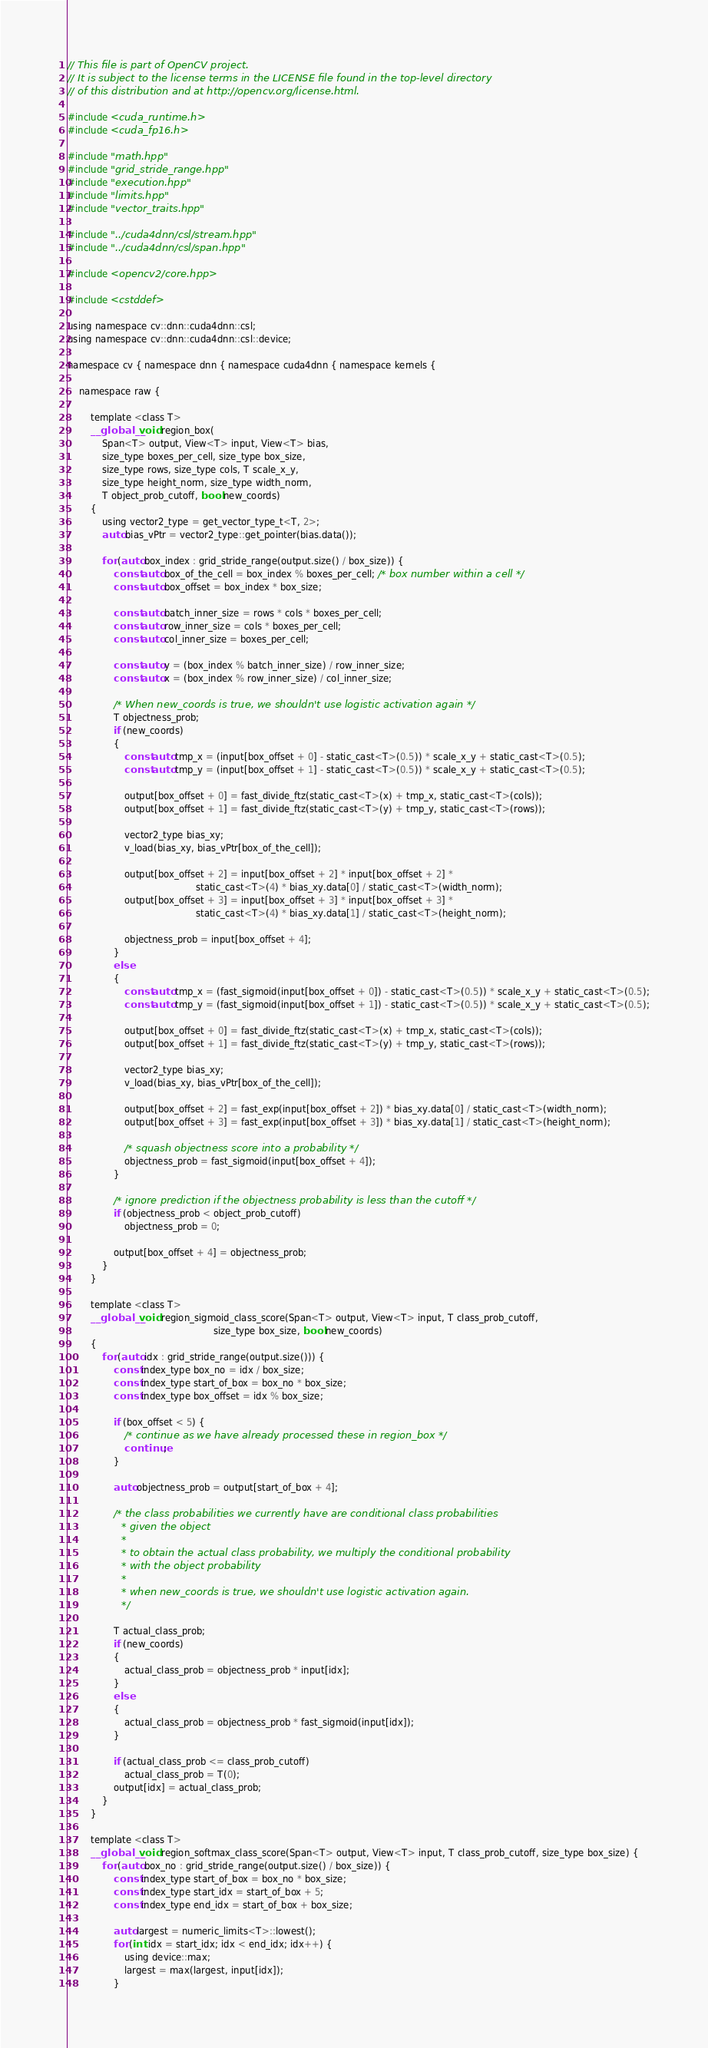Convert code to text. <code><loc_0><loc_0><loc_500><loc_500><_Cuda_>// This file is part of OpenCV project.
// It is subject to the license terms in the LICENSE file found in the top-level directory
// of this distribution and at http://opencv.org/license.html.

#include <cuda_runtime.h>
#include <cuda_fp16.h>

#include "math.hpp"
#include "grid_stride_range.hpp"
#include "execution.hpp"
#include "limits.hpp"
#include "vector_traits.hpp"

#include "../cuda4dnn/csl/stream.hpp"
#include "../cuda4dnn/csl/span.hpp"

#include <opencv2/core.hpp>

#include <cstddef>

using namespace cv::dnn::cuda4dnn::csl;
using namespace cv::dnn::cuda4dnn::csl::device;

namespace cv { namespace dnn { namespace cuda4dnn { namespace kernels {

    namespace raw {

        template <class T>
        __global__ void region_box(
            Span<T> output, View<T> input, View<T> bias,
            size_type boxes_per_cell, size_type box_size,
            size_type rows, size_type cols, T scale_x_y,
            size_type height_norm, size_type width_norm,
            T object_prob_cutoff, bool new_coords)
        {
            using vector2_type = get_vector_type_t<T, 2>;
            auto bias_vPtr = vector2_type::get_pointer(bias.data());

            for (auto box_index : grid_stride_range(output.size() / box_size)) {
                const auto box_of_the_cell = box_index % boxes_per_cell; /* box number within a cell */
                const auto box_offset = box_index * box_size;

                const auto batch_inner_size = rows * cols * boxes_per_cell;
                const auto row_inner_size = cols * boxes_per_cell;
                const auto col_inner_size = boxes_per_cell;

                const auto y = (box_index % batch_inner_size) / row_inner_size;
                const auto x = (box_index % row_inner_size) / col_inner_size;

                /* When new_coords is true, we shouldn't use logistic activation again */
                T objectness_prob;
                if (new_coords)
                {
                    const auto tmp_x = (input[box_offset + 0] - static_cast<T>(0.5)) * scale_x_y + static_cast<T>(0.5);
                    const auto tmp_y = (input[box_offset + 1] - static_cast<T>(0.5)) * scale_x_y + static_cast<T>(0.5);

                    output[box_offset + 0] = fast_divide_ftz(static_cast<T>(x) + tmp_x, static_cast<T>(cols));
                    output[box_offset + 1] = fast_divide_ftz(static_cast<T>(y) + tmp_y, static_cast<T>(rows));

                    vector2_type bias_xy;
                    v_load(bias_xy, bias_vPtr[box_of_the_cell]);

                    output[box_offset + 2] = input[box_offset + 2] * input[box_offset + 2] *
                                             static_cast<T>(4) * bias_xy.data[0] / static_cast<T>(width_norm);
                    output[box_offset + 3] = input[box_offset + 3] * input[box_offset + 3] *
                                             static_cast<T>(4) * bias_xy.data[1] / static_cast<T>(height_norm);

                    objectness_prob = input[box_offset + 4];
                }
                else
                {
                    const auto tmp_x = (fast_sigmoid(input[box_offset + 0]) - static_cast<T>(0.5)) * scale_x_y + static_cast<T>(0.5);
                    const auto tmp_y = (fast_sigmoid(input[box_offset + 1]) - static_cast<T>(0.5)) * scale_x_y + static_cast<T>(0.5);

                    output[box_offset + 0] = fast_divide_ftz(static_cast<T>(x) + tmp_x, static_cast<T>(cols));
                    output[box_offset + 1] = fast_divide_ftz(static_cast<T>(y) + tmp_y, static_cast<T>(rows));

                    vector2_type bias_xy;
                    v_load(bias_xy, bias_vPtr[box_of_the_cell]);

                    output[box_offset + 2] = fast_exp(input[box_offset + 2]) * bias_xy.data[0] / static_cast<T>(width_norm);
                    output[box_offset + 3] = fast_exp(input[box_offset + 3]) * bias_xy.data[1] / static_cast<T>(height_norm);

                    /* squash objectness score into a probability */
                    objectness_prob = fast_sigmoid(input[box_offset + 4]);
                }

                /* ignore prediction if the objectness probability is less than the cutoff */
                if (objectness_prob < object_prob_cutoff)
                    objectness_prob = 0;

                output[box_offset + 4] = objectness_prob;
            }
        }

        template <class T>
        __global__ void region_sigmoid_class_score(Span<T> output, View<T> input, T class_prob_cutoff,
                                                   size_type box_size, bool new_coords)
        {
            for (auto idx : grid_stride_range(output.size())) {
                const index_type box_no = idx / box_size;
                const index_type start_of_box = box_no * box_size;
                const index_type box_offset = idx % box_size;

                if (box_offset < 5) {
                    /* continue as we have already processed these in region_box */
                    continue;
                }

                auto objectness_prob = output[start_of_box + 4];

                /* the class probabilities we currently have are conditional class probabilities
                 * given the object
                 *
                 * to obtain the actual class probability, we multiply the conditional probability
                 * with the object probability
                 *
                 * when new_coords is true, we shouldn't use logistic activation again.
                 */

                T actual_class_prob;
                if (new_coords)
                {
                    actual_class_prob = objectness_prob * input[idx];
                }
                else
                {
                    actual_class_prob = objectness_prob * fast_sigmoid(input[idx]);
                }

                if (actual_class_prob <= class_prob_cutoff)
                    actual_class_prob = T(0);
                output[idx] = actual_class_prob;
            }
        }

        template <class T>
        __global__ void region_softmax_class_score(Span<T> output, View<T> input, T class_prob_cutoff, size_type box_size) {
            for (auto box_no : grid_stride_range(output.size() / box_size)) {
                const index_type start_of_box = box_no * box_size;
                const index_type start_idx = start_of_box + 5;
                const index_type end_idx = start_of_box + box_size;

                auto largest = numeric_limits<T>::lowest();
                for (int idx = start_idx; idx < end_idx; idx++) {
                    using device::max;
                    largest = max(largest, input[idx]);
                }
</code> 